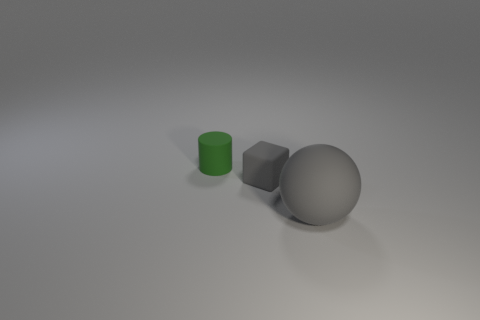Is the number of gray matte things that are to the left of the large gray thing greater than the number of matte cylinders?
Your response must be concise. No. What is the shape of the rubber object on the right side of the small thing that is to the right of the small matte thing that is on the left side of the tiny gray matte thing?
Provide a succinct answer. Sphere. Do the gray matte object in front of the gray block and the rubber cylinder have the same size?
Provide a short and direct response. No. The rubber object that is both behind the large rubber thing and in front of the small green rubber cylinder has what shape?
Your response must be concise. Cube. There is a tiny matte block; does it have the same color as the matte thing that is right of the rubber block?
Offer a very short reply. Yes. There is a rubber object behind the gray thing behind the matte object right of the block; what color is it?
Offer a very short reply. Green. Are there the same number of green rubber cylinders behind the small green cylinder and large objects?
Your response must be concise. No. How many spheres are either big gray rubber objects or gray things?
Provide a short and direct response. 1. There is a ball that is the same material as the tiny green cylinder; what color is it?
Provide a short and direct response. Gray. Is the tiny cylinder made of the same material as the gray object left of the large gray rubber ball?
Keep it short and to the point. Yes. 